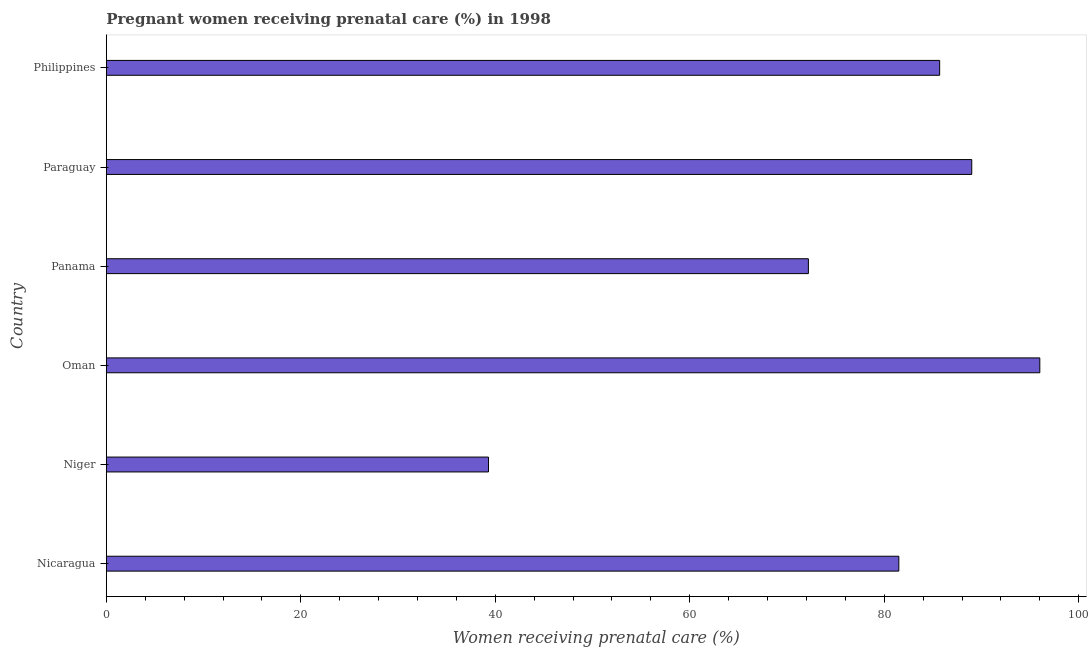Does the graph contain any zero values?
Your answer should be compact. No. Does the graph contain grids?
Give a very brief answer. No. What is the title of the graph?
Keep it short and to the point. Pregnant women receiving prenatal care (%) in 1998. What is the label or title of the X-axis?
Make the answer very short. Women receiving prenatal care (%). What is the percentage of pregnant women receiving prenatal care in Paraguay?
Ensure brevity in your answer.  89. Across all countries, what is the maximum percentage of pregnant women receiving prenatal care?
Offer a terse response. 96. Across all countries, what is the minimum percentage of pregnant women receiving prenatal care?
Give a very brief answer. 39.3. In which country was the percentage of pregnant women receiving prenatal care maximum?
Provide a short and direct response. Oman. In which country was the percentage of pregnant women receiving prenatal care minimum?
Provide a short and direct response. Niger. What is the sum of the percentage of pregnant women receiving prenatal care?
Offer a very short reply. 463.7. What is the difference between the percentage of pregnant women receiving prenatal care in Paraguay and Philippines?
Make the answer very short. 3.3. What is the average percentage of pregnant women receiving prenatal care per country?
Provide a succinct answer. 77.28. What is the median percentage of pregnant women receiving prenatal care?
Offer a terse response. 83.6. In how many countries, is the percentage of pregnant women receiving prenatal care greater than 44 %?
Your answer should be very brief. 5. What is the ratio of the percentage of pregnant women receiving prenatal care in Paraguay to that in Philippines?
Keep it short and to the point. 1.04. Is the sum of the percentage of pregnant women receiving prenatal care in Nicaragua and Niger greater than the maximum percentage of pregnant women receiving prenatal care across all countries?
Provide a short and direct response. Yes. What is the difference between the highest and the lowest percentage of pregnant women receiving prenatal care?
Provide a succinct answer. 56.7. In how many countries, is the percentage of pregnant women receiving prenatal care greater than the average percentage of pregnant women receiving prenatal care taken over all countries?
Provide a succinct answer. 4. How many bars are there?
Make the answer very short. 6. How many countries are there in the graph?
Your response must be concise. 6. What is the Women receiving prenatal care (%) in Nicaragua?
Make the answer very short. 81.5. What is the Women receiving prenatal care (%) in Niger?
Provide a short and direct response. 39.3. What is the Women receiving prenatal care (%) in Oman?
Your answer should be very brief. 96. What is the Women receiving prenatal care (%) in Panama?
Provide a succinct answer. 72.2. What is the Women receiving prenatal care (%) of Paraguay?
Provide a succinct answer. 89. What is the Women receiving prenatal care (%) of Philippines?
Your answer should be very brief. 85.7. What is the difference between the Women receiving prenatal care (%) in Nicaragua and Niger?
Your answer should be very brief. 42.2. What is the difference between the Women receiving prenatal care (%) in Nicaragua and Paraguay?
Your answer should be very brief. -7.5. What is the difference between the Women receiving prenatal care (%) in Nicaragua and Philippines?
Provide a succinct answer. -4.2. What is the difference between the Women receiving prenatal care (%) in Niger and Oman?
Your response must be concise. -56.7. What is the difference between the Women receiving prenatal care (%) in Niger and Panama?
Ensure brevity in your answer.  -32.9. What is the difference between the Women receiving prenatal care (%) in Niger and Paraguay?
Offer a very short reply. -49.7. What is the difference between the Women receiving prenatal care (%) in Niger and Philippines?
Offer a terse response. -46.4. What is the difference between the Women receiving prenatal care (%) in Oman and Panama?
Keep it short and to the point. 23.8. What is the difference between the Women receiving prenatal care (%) in Oman and Paraguay?
Your answer should be compact. 7. What is the difference between the Women receiving prenatal care (%) in Panama and Paraguay?
Provide a succinct answer. -16.8. What is the difference between the Women receiving prenatal care (%) in Paraguay and Philippines?
Your answer should be compact. 3.3. What is the ratio of the Women receiving prenatal care (%) in Nicaragua to that in Niger?
Your answer should be very brief. 2.07. What is the ratio of the Women receiving prenatal care (%) in Nicaragua to that in Oman?
Provide a short and direct response. 0.85. What is the ratio of the Women receiving prenatal care (%) in Nicaragua to that in Panama?
Your answer should be compact. 1.13. What is the ratio of the Women receiving prenatal care (%) in Nicaragua to that in Paraguay?
Offer a very short reply. 0.92. What is the ratio of the Women receiving prenatal care (%) in Nicaragua to that in Philippines?
Keep it short and to the point. 0.95. What is the ratio of the Women receiving prenatal care (%) in Niger to that in Oman?
Make the answer very short. 0.41. What is the ratio of the Women receiving prenatal care (%) in Niger to that in Panama?
Make the answer very short. 0.54. What is the ratio of the Women receiving prenatal care (%) in Niger to that in Paraguay?
Provide a short and direct response. 0.44. What is the ratio of the Women receiving prenatal care (%) in Niger to that in Philippines?
Make the answer very short. 0.46. What is the ratio of the Women receiving prenatal care (%) in Oman to that in Panama?
Your response must be concise. 1.33. What is the ratio of the Women receiving prenatal care (%) in Oman to that in Paraguay?
Provide a short and direct response. 1.08. What is the ratio of the Women receiving prenatal care (%) in Oman to that in Philippines?
Your response must be concise. 1.12. What is the ratio of the Women receiving prenatal care (%) in Panama to that in Paraguay?
Make the answer very short. 0.81. What is the ratio of the Women receiving prenatal care (%) in Panama to that in Philippines?
Offer a terse response. 0.84. What is the ratio of the Women receiving prenatal care (%) in Paraguay to that in Philippines?
Provide a succinct answer. 1.04. 